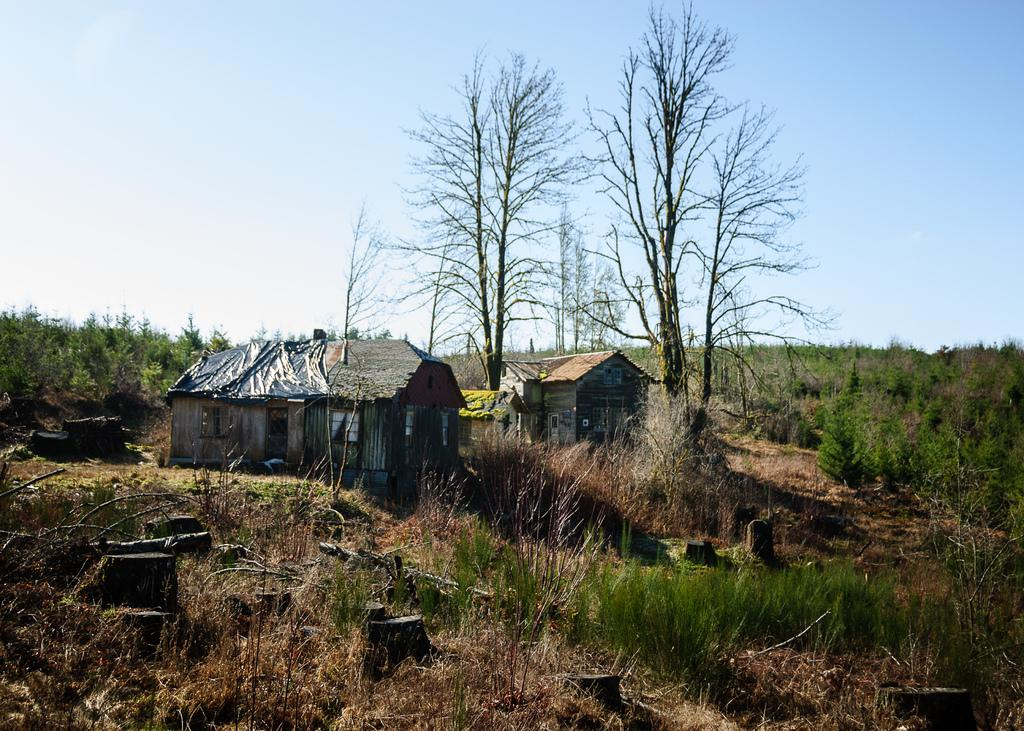How many houses can be seen in the image? There are two houses in the image. What is located in the middle of the image? Trees are present in the middle of the image. What type of vegetation is at the bottom of the image? There is grass at the bottom of the image. What can be seen in the background of the image? There are plants visible in the background of the image. What is visible at the top of the image? The sky is visible at the top of the image. What type of coil can be seen in the image? There is no coil present in the image. Can you recite the verse that is written on the trees in the image? There are no verses written on the trees in the image; they are simply depicted as trees. 